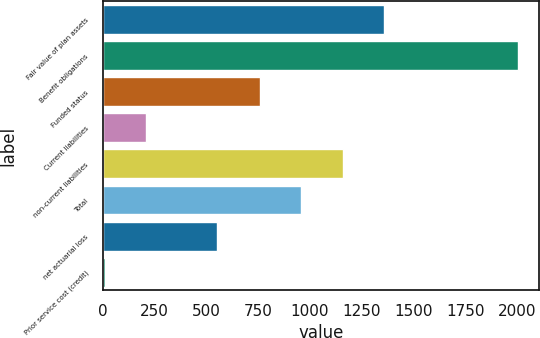<chart> <loc_0><loc_0><loc_500><loc_500><bar_chart><fcel>Fair value of plan assets<fcel>Benefit obligations<fcel>Funded status<fcel>Current liabilities<fcel>non-current liabilities<fcel>Total<fcel>net actuarial loss<fcel>Prior service cost (credit)<nl><fcel>1357.1<fcel>2006<fcel>758<fcel>208.7<fcel>1157.4<fcel>957.7<fcel>550<fcel>9<nl></chart> 